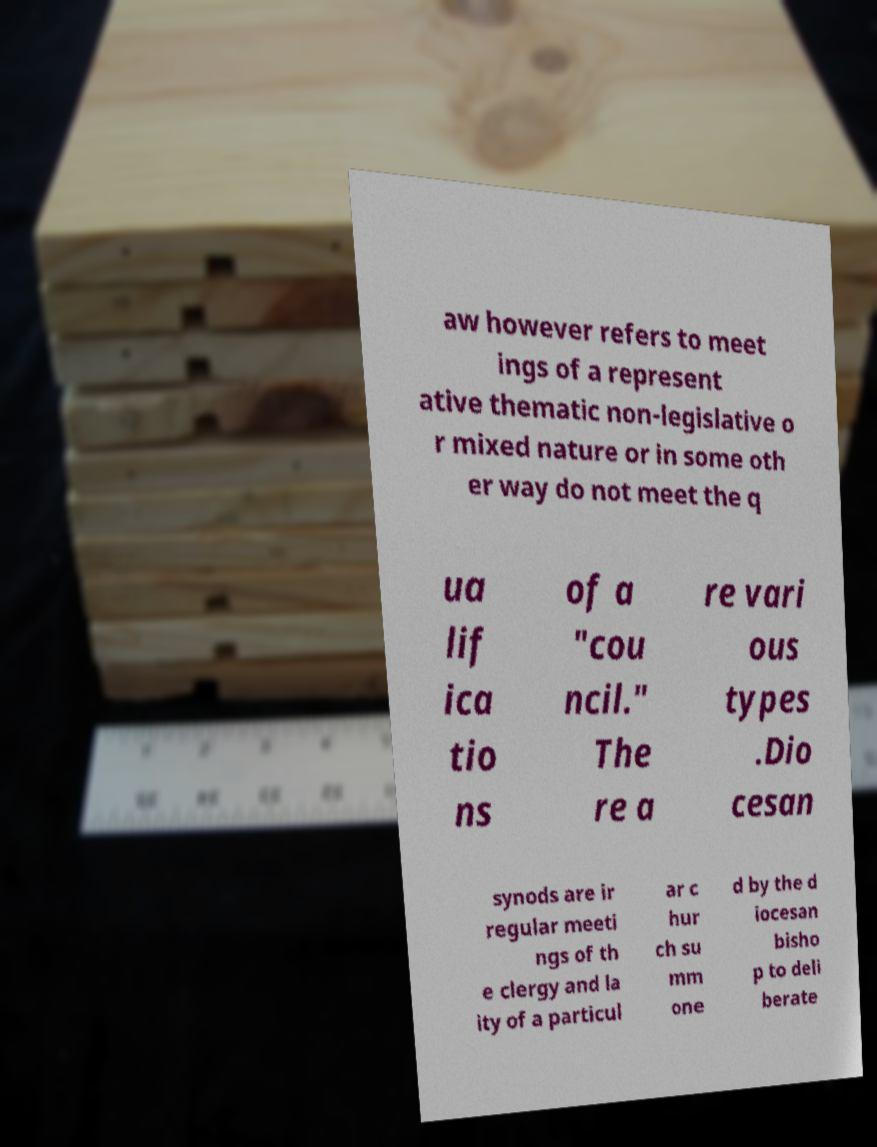I need the written content from this picture converted into text. Can you do that? aw however refers to meet ings of a represent ative thematic non-legislative o r mixed nature or in some oth er way do not meet the q ua lif ica tio ns of a "cou ncil." The re a re vari ous types .Dio cesan synods are ir regular meeti ngs of th e clergy and la ity of a particul ar c hur ch su mm one d by the d iocesan bisho p to deli berate 